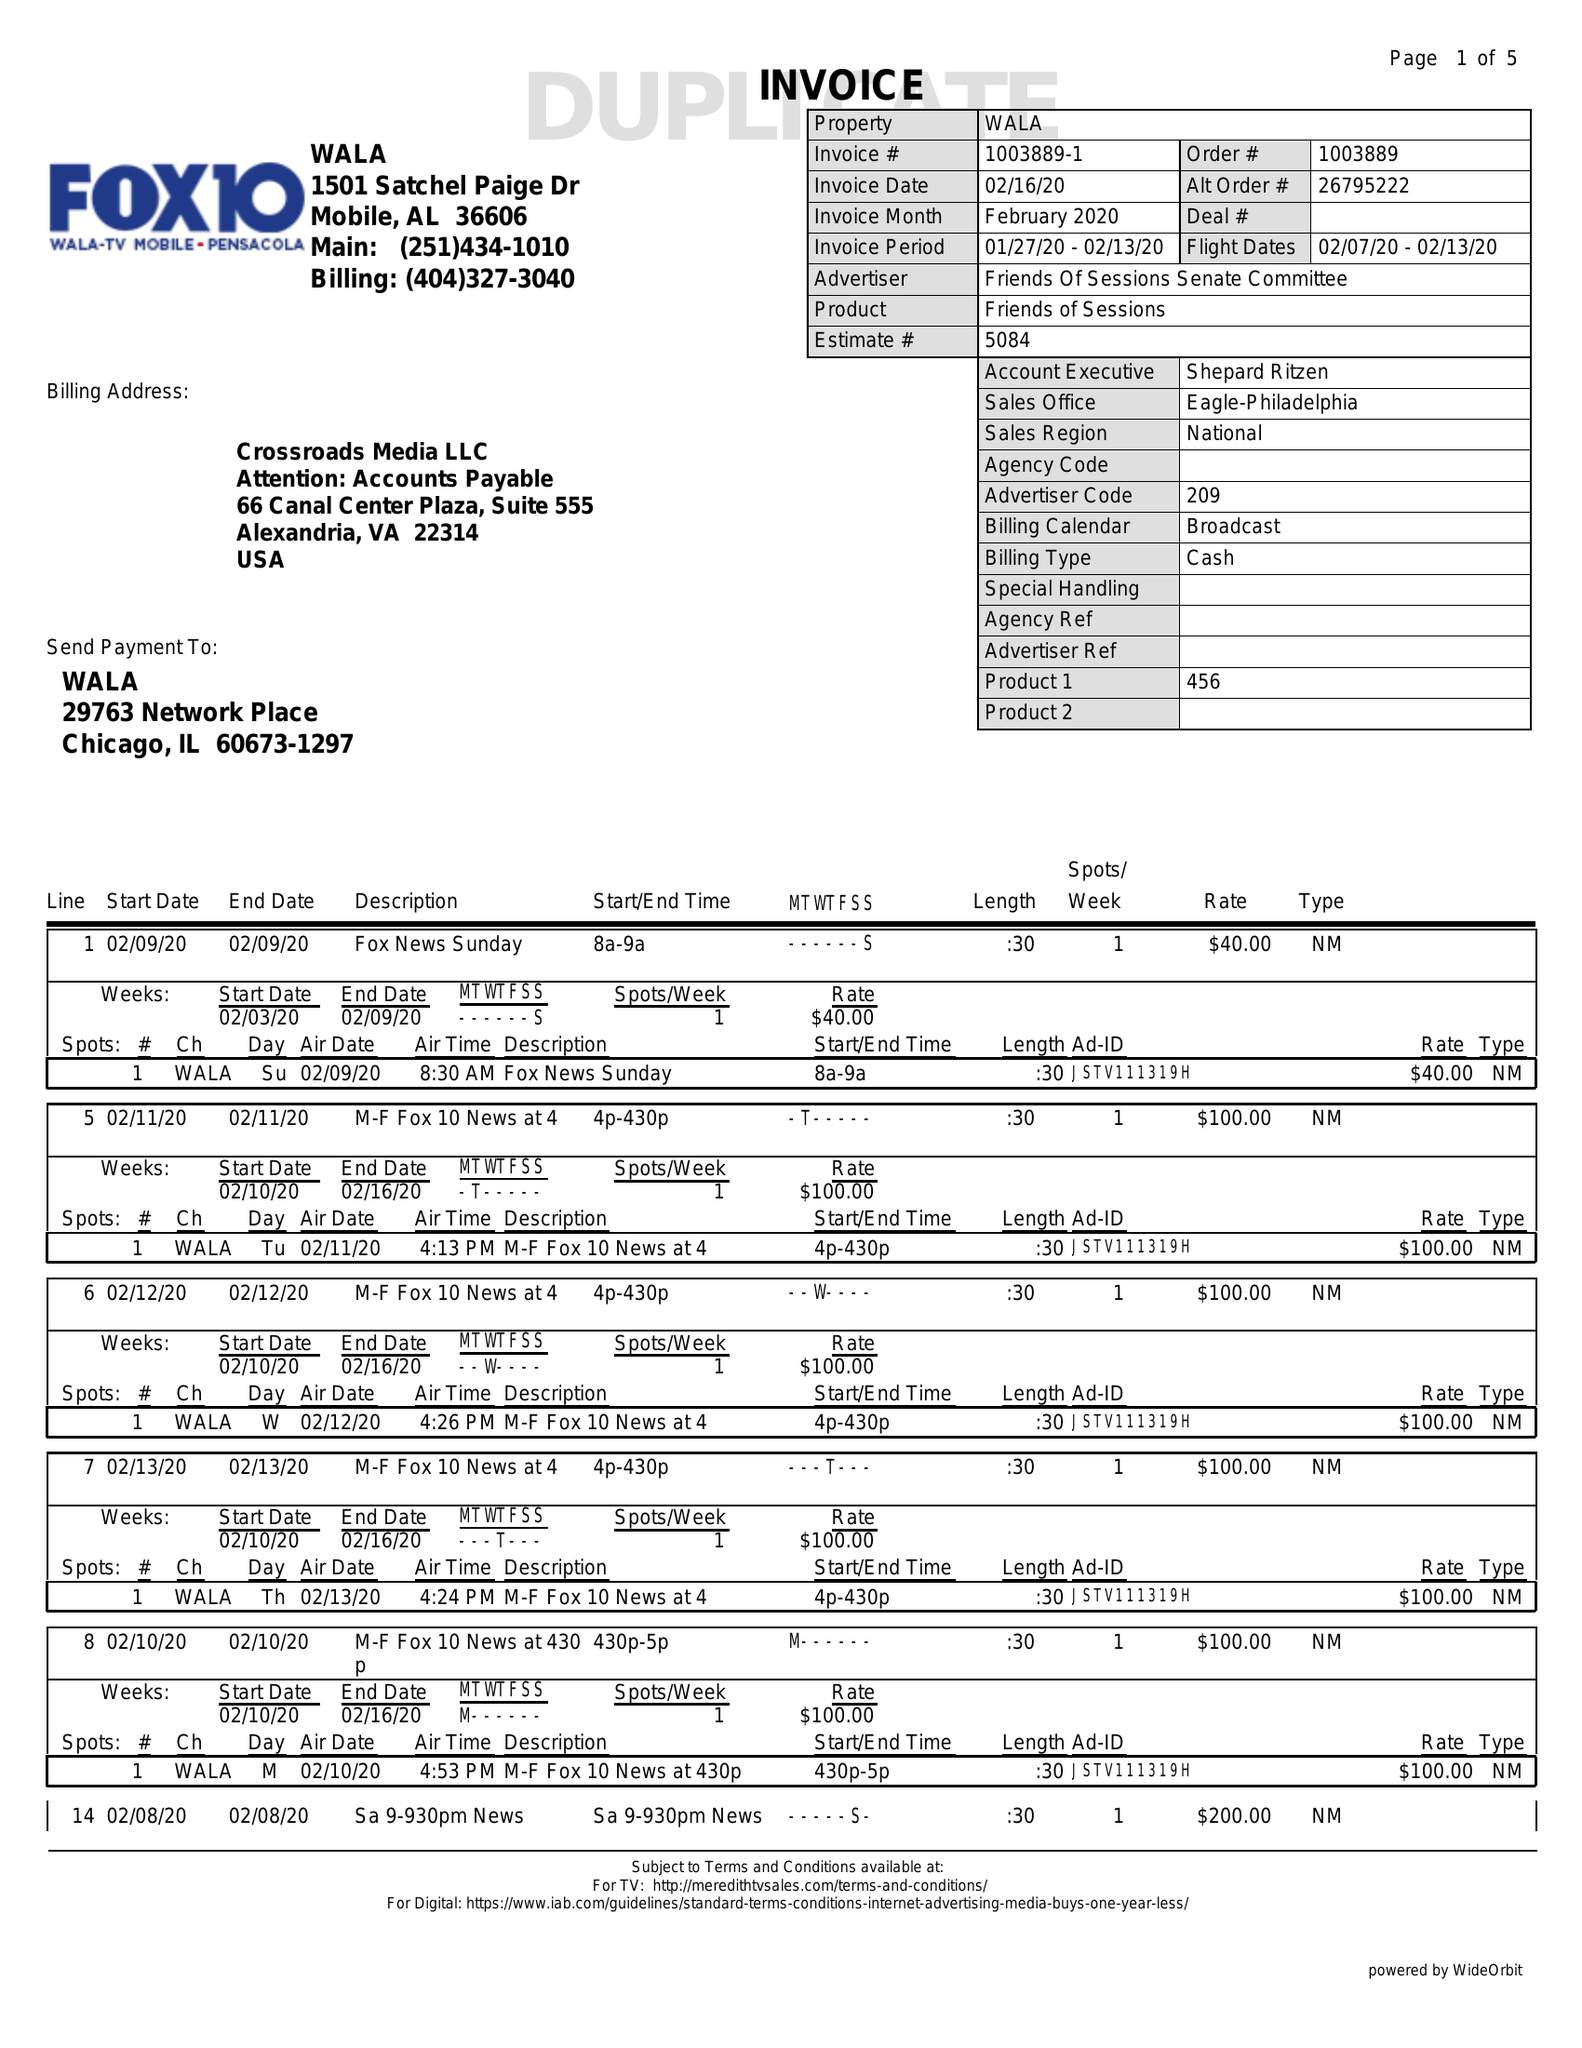What is the value for the contract_num?
Answer the question using a single word or phrase. 1003889 